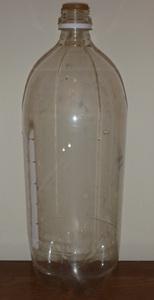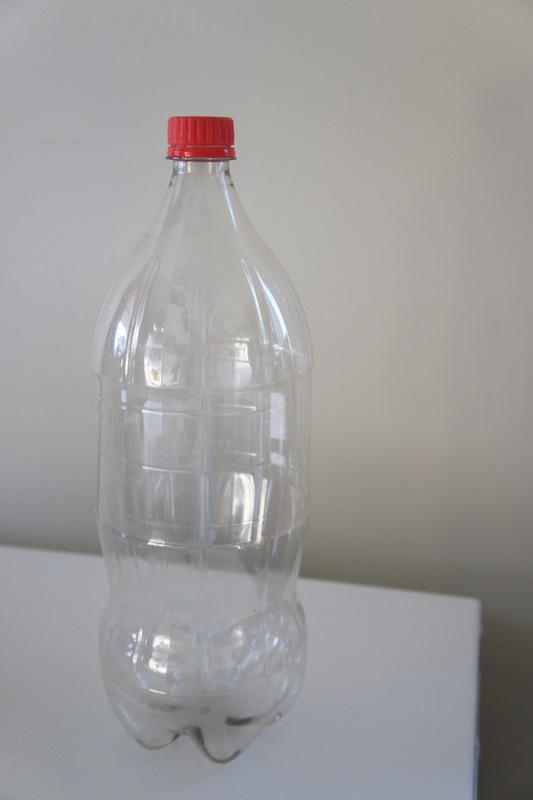The first image is the image on the left, the second image is the image on the right. For the images shown, is this caption "At least two bottles have caps on them." true? Answer yes or no. No. The first image is the image on the left, the second image is the image on the right. Assess this claim about the two images: "One of the pictures shows at least two bottles standing upright side by side.". Correct or not? Answer yes or no. No. 